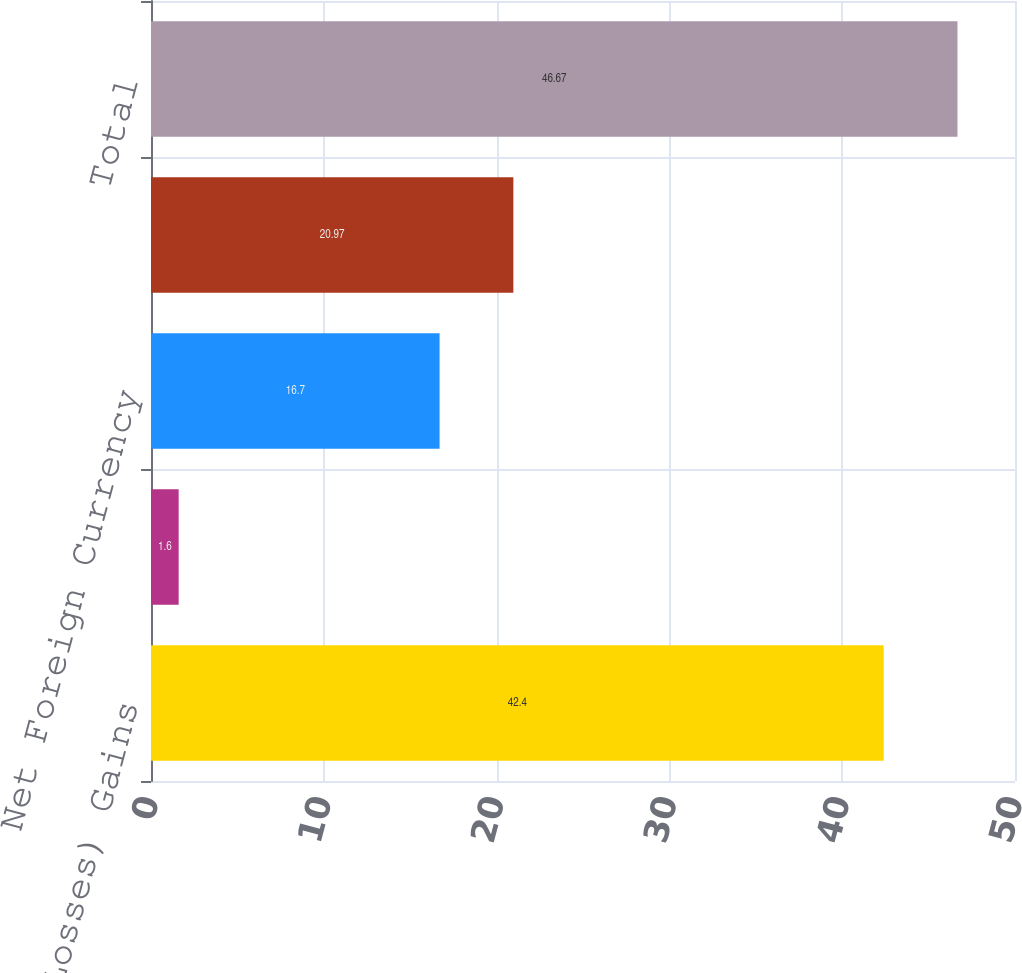Convert chart. <chart><loc_0><loc_0><loc_500><loc_500><bar_chart><fcel>Net Unrealized (Losses) Gains<fcel>Net Unrealized Gains (Losses)<fcel>Net Foreign Currency<fcel>Net Pension and Other<fcel>Total<nl><fcel>42.4<fcel>1.6<fcel>16.7<fcel>20.97<fcel>46.67<nl></chart> 